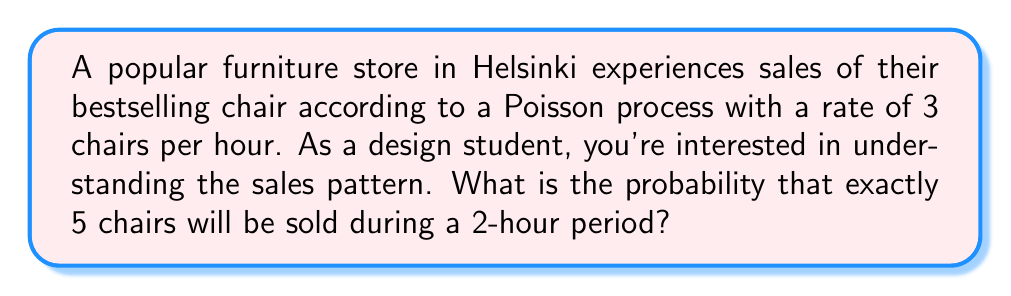Give your solution to this math problem. Let's approach this step-by-step:

1) The Poisson process has a rate $\lambda = 3$ chairs per hour.

2) We're looking at a 2-hour period, so we need to adjust our rate:
   $\lambda_t = 3 \cdot 2 = 6$ chairs per 2-hour period

3) The probability of exactly $k$ events occurring in a Poisson process over a time period $t$ is given by the Poisson probability mass function:

   $$P(X = k) = \frac{e^{-\lambda_t} (\lambda_t)^k}{k!}$$

4) In this case, we want $P(X = 5)$ where $\lambda_t = 6$:

   $$P(X = 5) = \frac{e^{-6} (6)^5}{5!}$$

5) Let's calculate this step-by-step:
   
   $$\begin{align}
   P(X = 5) &= \frac{e^{-6} \cdot 6^5}{5!} \\
   &= \frac{e^{-6} \cdot 7776}{120} \\
   &\approx 0.1606
   \end{align}$$

6) Converting to a percentage: 0.1606 * 100 ≈ 16.06%

Therefore, the probability of exactly 5 chairs being sold during a 2-hour period is approximately 16.06%.
Answer: 16.06% 